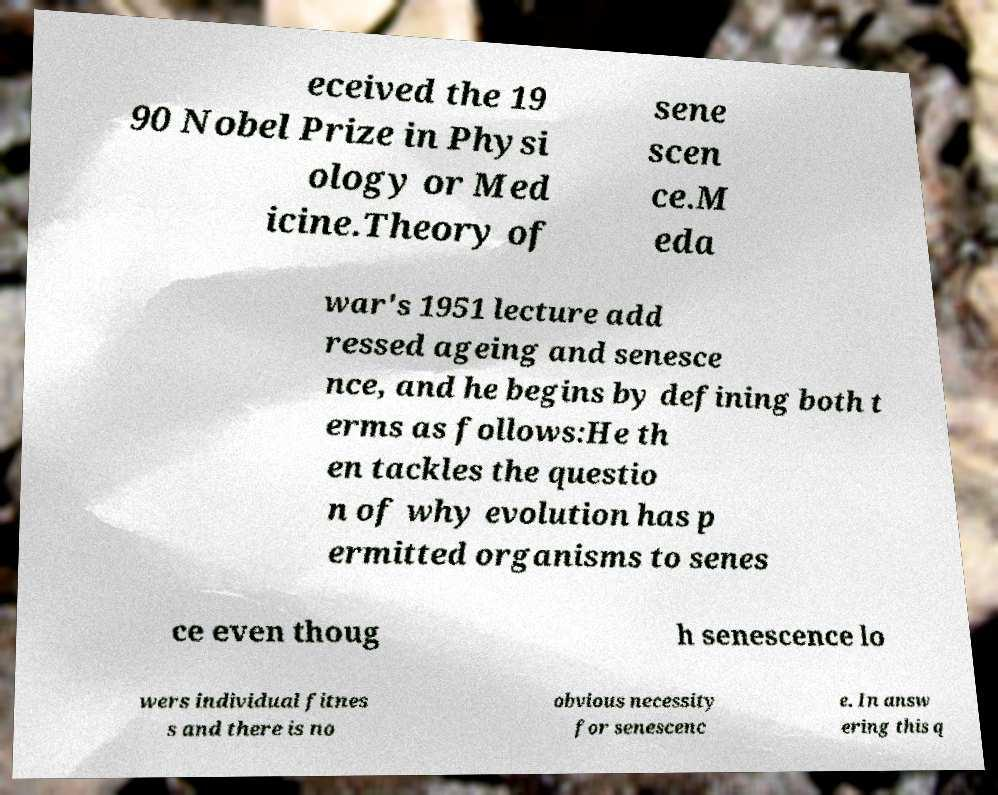I need the written content from this picture converted into text. Can you do that? eceived the 19 90 Nobel Prize in Physi ology or Med icine.Theory of sene scen ce.M eda war's 1951 lecture add ressed ageing and senesce nce, and he begins by defining both t erms as follows:He th en tackles the questio n of why evolution has p ermitted organisms to senes ce even thoug h senescence lo wers individual fitnes s and there is no obvious necessity for senescenc e. In answ ering this q 